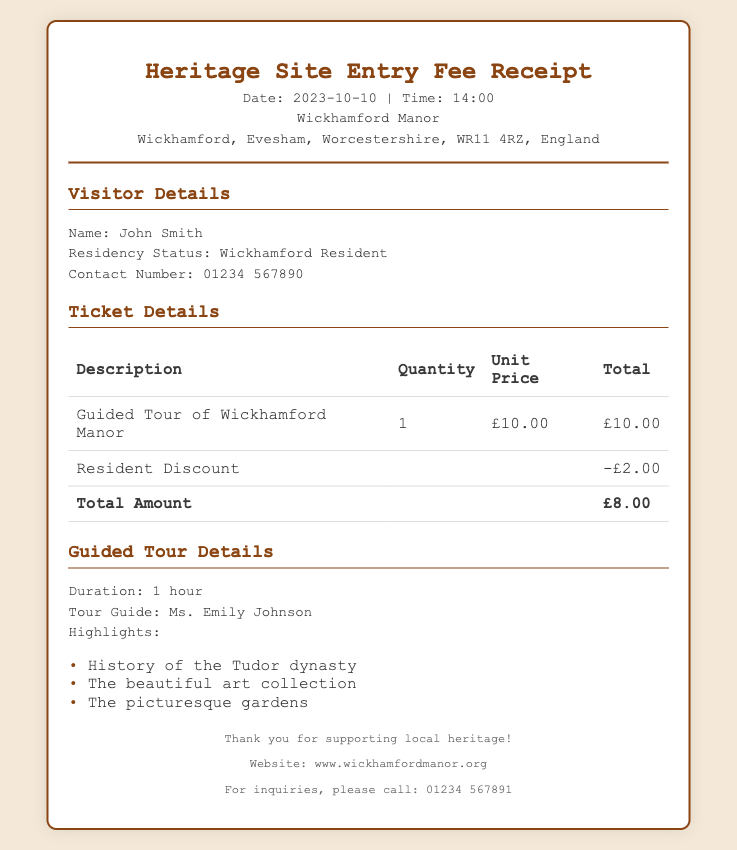What is the date of the receipt? The date mentioned in the receipt is prominently stated at the top.
Answer: 2023-10-10 What is the total amount after the resident discount? The total amount is calculated after applying the resident discount of £2.00.
Answer: £8.00 Who was the tour guide for the visit? The name of the tour guide is provided in the guided tour details section.
Answer: Ms. Emily Johnson What is the duration of the guided tour? The duration for the guided tour is specified in the details section.
Answer: 1 hour What is the residency status of the visitor? The residency status is found under the visitor details section indicating where the visitor resides.
Answer: Wickhamford Resident What is the address of Wickhamford Manor? The complete address is listed in the header section of the receipt.
Answer: Wickhamford, Evesham, Worcestershire, WR11 4RZ, England What is the resident discount in pounds? The resident discount amount is mentioned in the ticket details section.
Answer: -£2.00 What are the highlights of the guided tour? The highlights of the tour are listed as bullet points in the guided tour details section.
Answer: History of the Tudor dynasty, The beautiful art collection, The picturesque gardens 